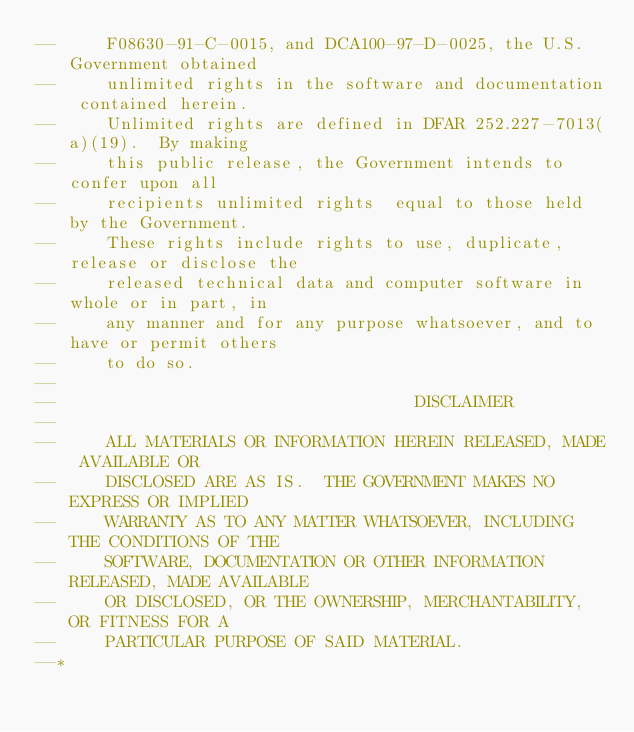<code> <loc_0><loc_0><loc_500><loc_500><_Ada_>--     F08630-91-C-0015, and DCA100-97-D-0025, the U.S. Government obtained 
--     unlimited rights in the software and documentation contained herein.
--     Unlimited rights are defined in DFAR 252.227-7013(a)(19).  By making 
--     this public release, the Government intends to confer upon all 
--     recipients unlimited rights  equal to those held by the Government.  
--     These rights include rights to use, duplicate, release or disclose the 
--     released technical data and computer software in whole or in part, in 
--     any manner and for any purpose whatsoever, and to have or permit others 
--     to do so.
--
--                                    DISCLAIMER
--
--     ALL MATERIALS OR INFORMATION HEREIN RELEASED, MADE AVAILABLE OR
--     DISCLOSED ARE AS IS.  THE GOVERNMENT MAKES NO EXPRESS OR IMPLIED 
--     WARRANTY AS TO ANY MATTER WHATSOEVER, INCLUDING THE CONDITIONS OF THE
--     SOFTWARE, DOCUMENTATION OR OTHER INFORMATION RELEASED, MADE AVAILABLE 
--     OR DISCLOSED, OR THE OWNERSHIP, MERCHANTABILITY, OR FITNESS FOR A
--     PARTICULAR PURPOSE OF SAID MATERIAL.
--*</code> 